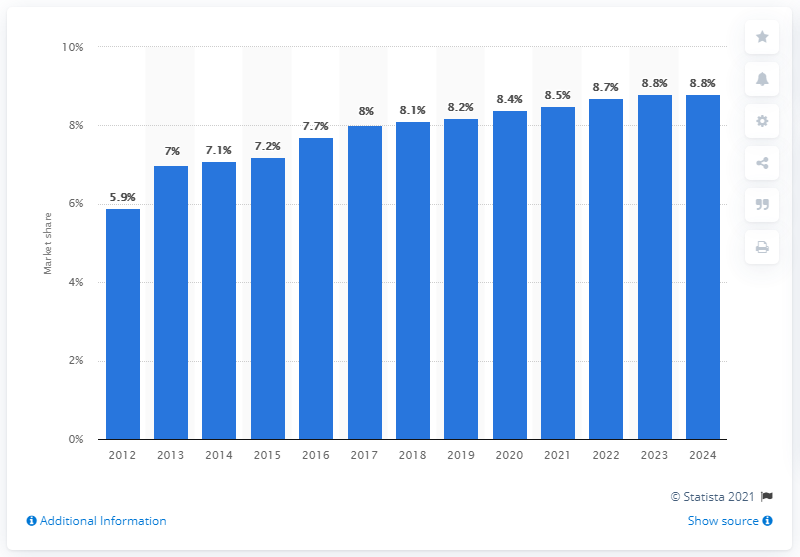Mention a couple of crucial points in this snapshot. The global fragrance products market in 2018 was 8.1% owned by Este Lauder. 